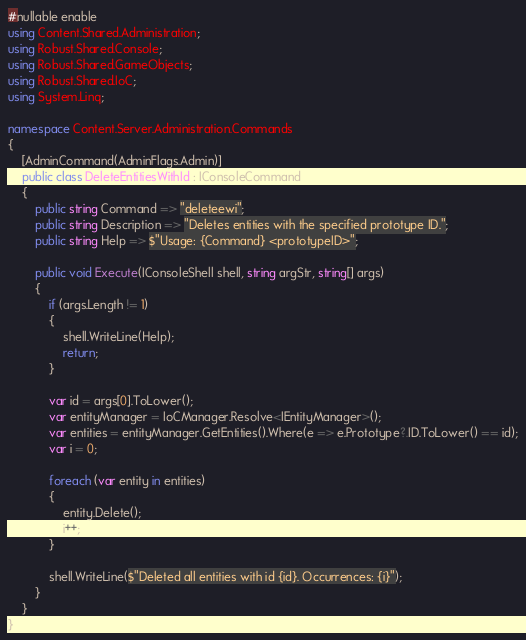Convert code to text. <code><loc_0><loc_0><loc_500><loc_500><_C#_>#nullable enable
using Content.Shared.Administration;
using Robust.Shared.Console;
using Robust.Shared.GameObjects;
using Robust.Shared.IoC;
using System.Linq;

namespace Content.Server.Administration.Commands
{
    [AdminCommand(AdminFlags.Admin)]
    public class DeleteEntitiesWithId : IConsoleCommand
    {
        public string Command => "deleteewi";
        public string Description => "Deletes entities with the specified prototype ID.";
        public string Help => $"Usage: {Command} <prototypeID>";

        public void Execute(IConsoleShell shell, string argStr, string[] args)
        {
            if (args.Length != 1)
            {
                shell.WriteLine(Help);
                return;
            }

            var id = args[0].ToLower();
            var entityManager = IoCManager.Resolve<IEntityManager>();
            var entities = entityManager.GetEntities().Where(e => e.Prototype?.ID.ToLower() == id);
            var i = 0;

            foreach (var entity in entities)
            {
                entity.Delete();
                i++;
            }

            shell.WriteLine($"Deleted all entities with id {id}. Occurrences: {i}");
        }
    }
}
</code> 